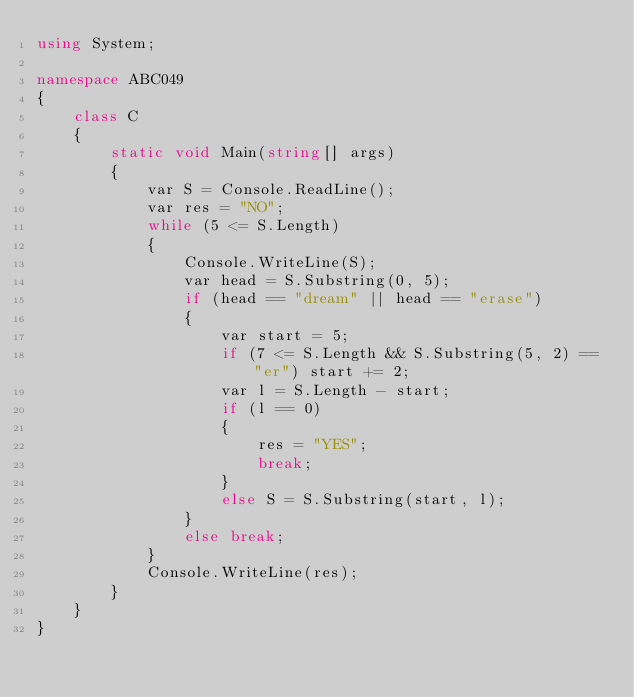<code> <loc_0><loc_0><loc_500><loc_500><_C#_>using System;

namespace ABC049
{
    class C
    {
        static void Main(string[] args)
        {
            var S = Console.ReadLine();
            var res = "NO";
            while (5 <= S.Length)
            {
                Console.WriteLine(S);
                var head = S.Substring(0, 5);
                if (head == "dream" || head == "erase")
                {
                    var start = 5;
                    if (7 <= S.Length && S.Substring(5, 2) == "er") start += 2;
                    var l = S.Length - start;
                    if (l == 0)
                    {
                        res = "YES";
                        break;
                    }
                    else S = S.Substring(start, l);
                }
                else break;
            }
            Console.WriteLine(res);
        }
    }
}
</code> 